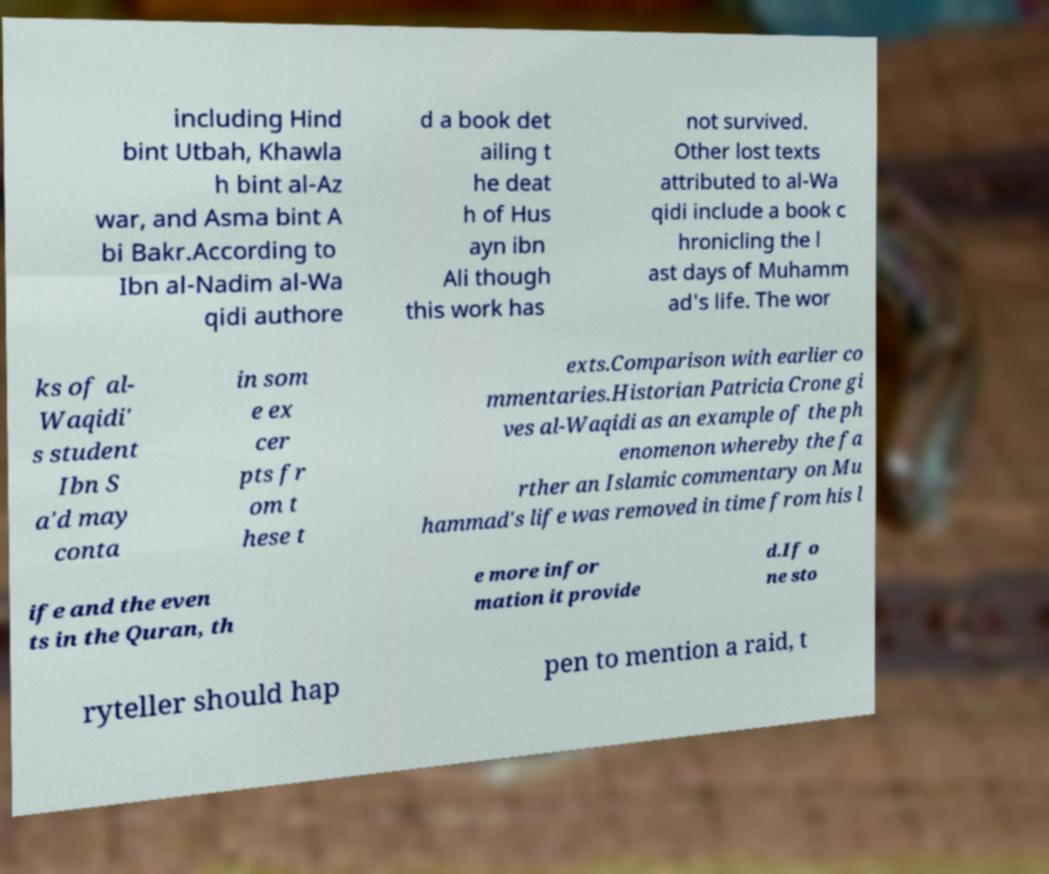There's text embedded in this image that I need extracted. Can you transcribe it verbatim? including Hind bint Utbah, Khawla h bint al-Az war, and Asma bint A bi Bakr.According to Ibn al-Nadim al-Wa qidi authore d a book det ailing t he deat h of Hus ayn ibn Ali though this work has not survived. Other lost texts attributed to al-Wa qidi include a book c hronicling the l ast days of Muhamm ad's life. The wor ks of al- Waqidi' s student Ibn S a'd may conta in som e ex cer pts fr om t hese t exts.Comparison with earlier co mmentaries.Historian Patricia Crone gi ves al-Waqidi as an example of the ph enomenon whereby the fa rther an Islamic commentary on Mu hammad's life was removed in time from his l ife and the even ts in the Quran, th e more infor mation it provide d.If o ne sto ryteller should hap pen to mention a raid, t 